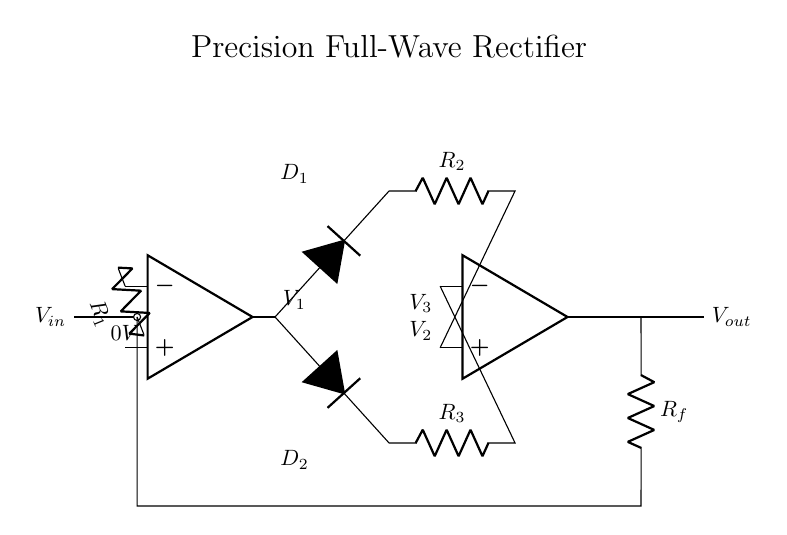What is the purpose of op-amp in this circuit? The op-amps in this circuit are used to amplify the input voltage and ensure that the output signal accurately represents the full-wave rectified version of the input. Each op-amp performs a specific function in the precision rectification process.
Answer: Amplification What is the role of the diodes in this rectifier? The diodes in this circuit allow current to flow in one direction, thus enabling the circuit to convert both halves of the input AC signal into a unidirectional (DC) output. Each diode conducts during different halves of the input cycle, allowing for full-wave rectification.
Answer: Unidirectional current What are the resistors R1, R2, R3, and Rf used for? The resistors are used for setting gain and establishing the feedback conditions in the op-amp circuits. R1 is for input resistance, R2 and R3 help in controlling the output for each half of the waveform, and Rf provides feedback to stabilize the output.
Answer: Gain and stability What is the expected output voltage relative to the input voltage? The output voltage will be approximately equal to the input voltage magnitude, but inverted in cases of negative input voltage due to how the rectifier functions across both halves of the waveform.
Answer: Approximately equal Which diodes conduct during the positive half of the input waveform? During the positive half of the input waveform, diode D1 conducts, allowing current to pass through and contributing to the output signal while D2 remains off.
Answer: D1 What characteristic of this rectifier distinguishes it from standard rectifiers? This rectifier is characterized by its use of op-amps for precision, meaning it can accurately rectify low-level signals without introducing significant error or voltage drop that regular diodes would cause.
Answer: Precision rectification How does this circuit handle negative input voltages? The circuit utilizes the op-amps and additional diodes to ensure that negative input voltages are still processed, allowing the output to remain positive while accurately reflecting the negative input. This ensures that the entire input waveform is rectified.
Answer: Full-wave processing 